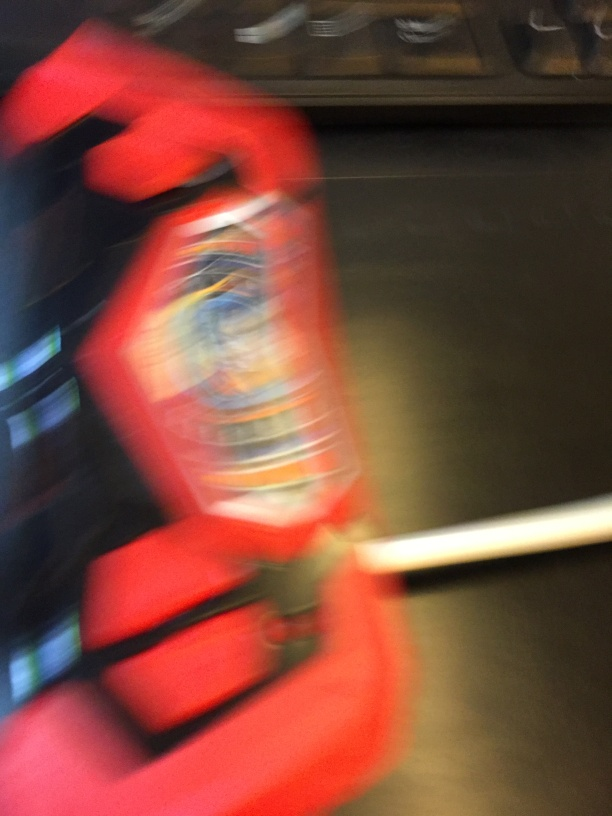Is the background blurry and lacking clarity? Yes, the background is blurry, contributing to a lack of clarity in the image. This effect, often due to motion or a narrow depth of field during the photograph's capture, forces the main object to stand out despite the motion blur affecting its details as well. 